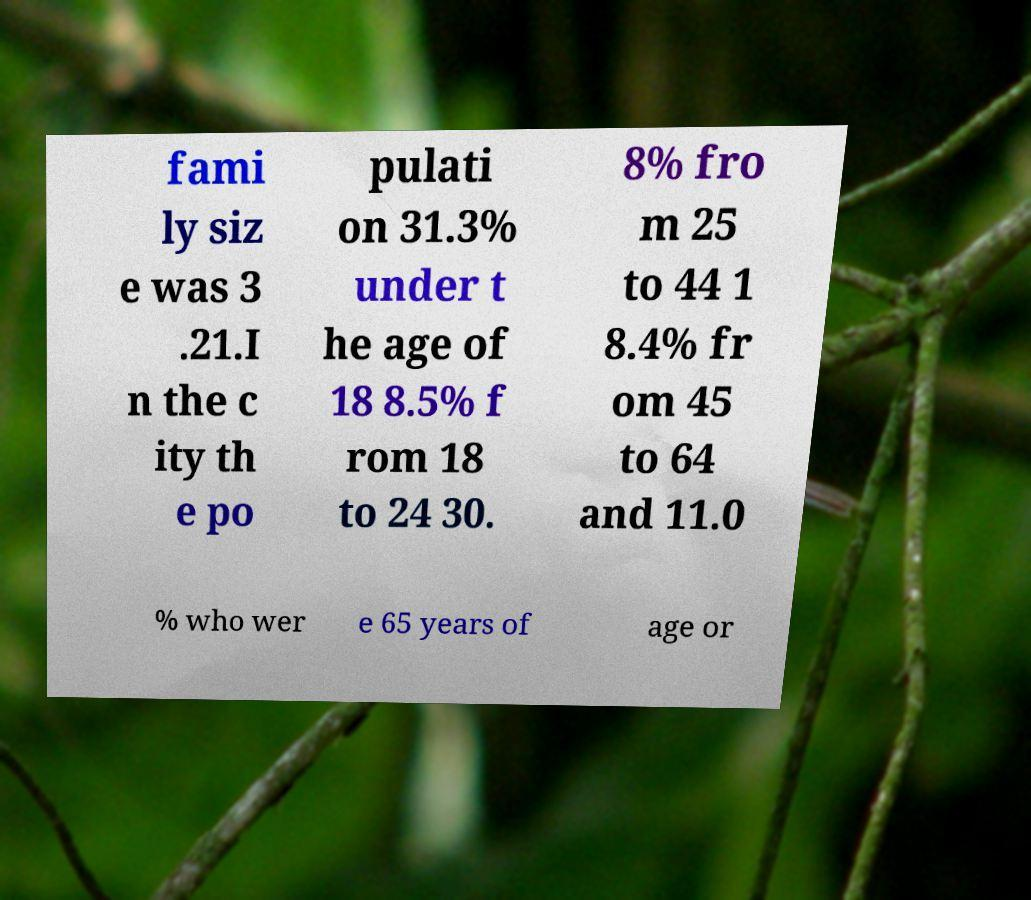Could you extract and type out the text from this image? fami ly siz e was 3 .21.I n the c ity th e po pulati on 31.3% under t he age of 18 8.5% f rom 18 to 24 30. 8% fro m 25 to 44 1 8.4% fr om 45 to 64 and 11.0 % who wer e 65 years of age or 